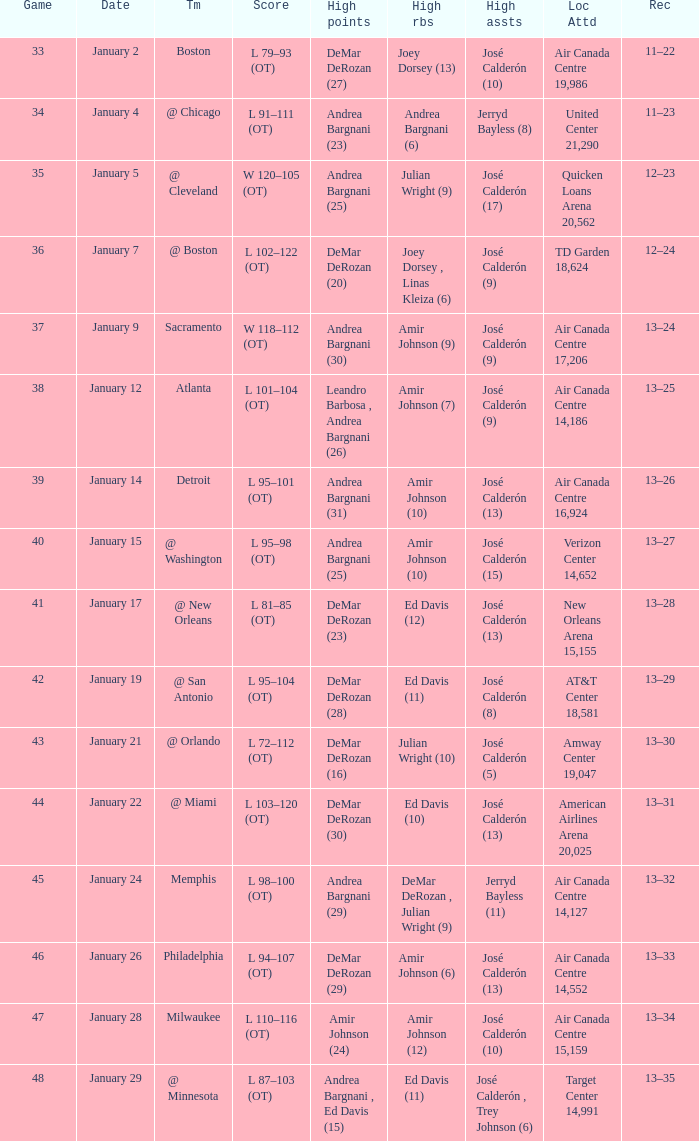Name the team for january 17 @ New Orleans. 